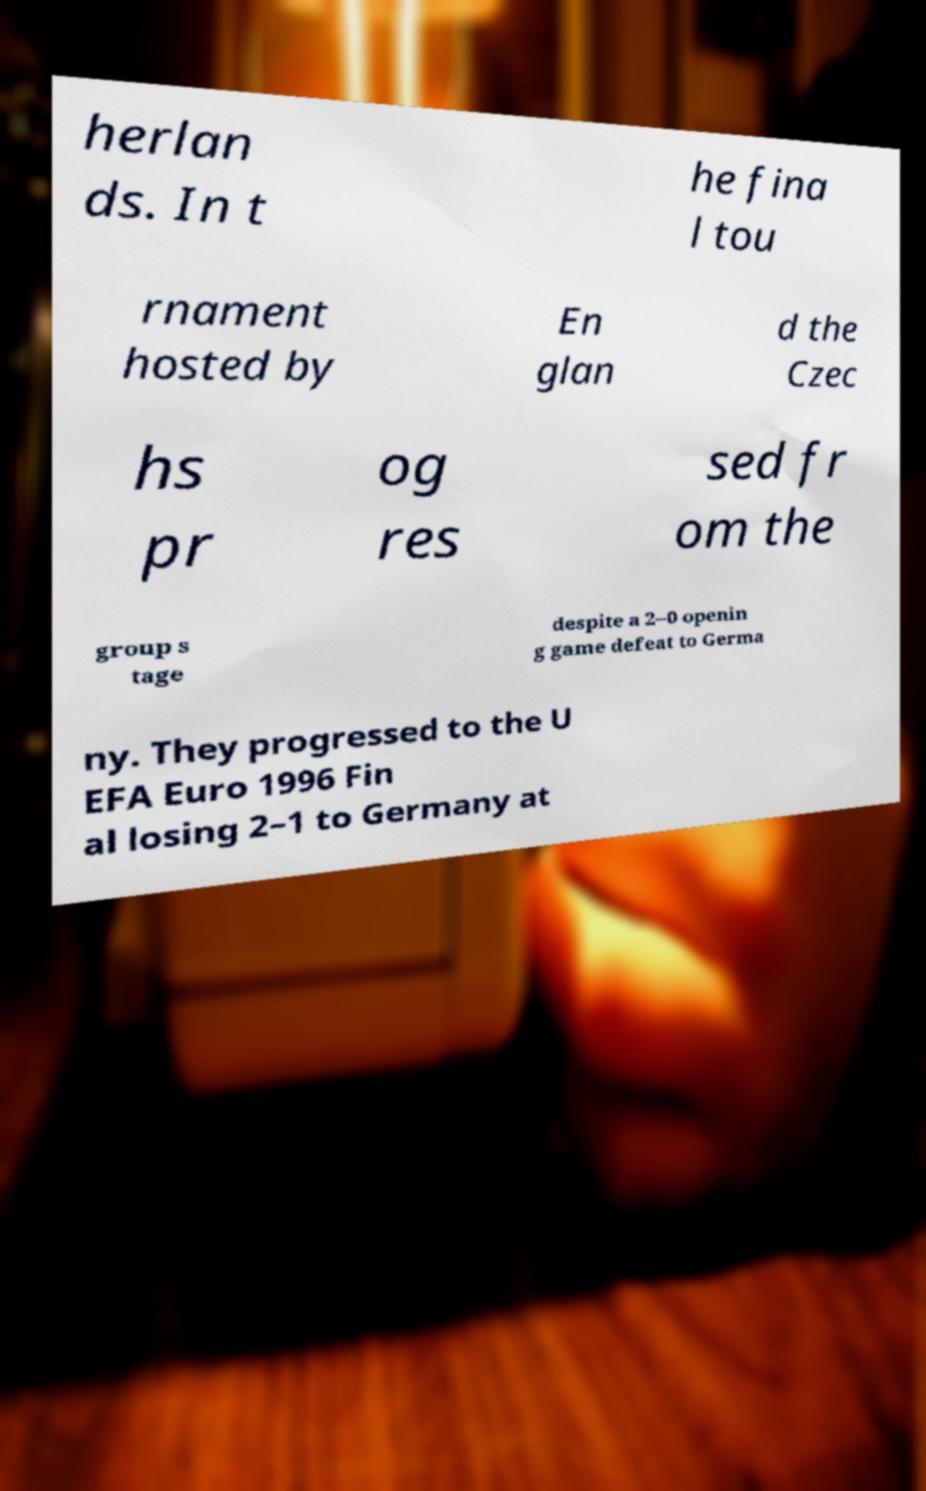I need the written content from this picture converted into text. Can you do that? herlan ds. In t he fina l tou rnament hosted by En glan d the Czec hs pr og res sed fr om the group s tage despite a 2–0 openin g game defeat to Germa ny. They progressed to the U EFA Euro 1996 Fin al losing 2–1 to Germany at 